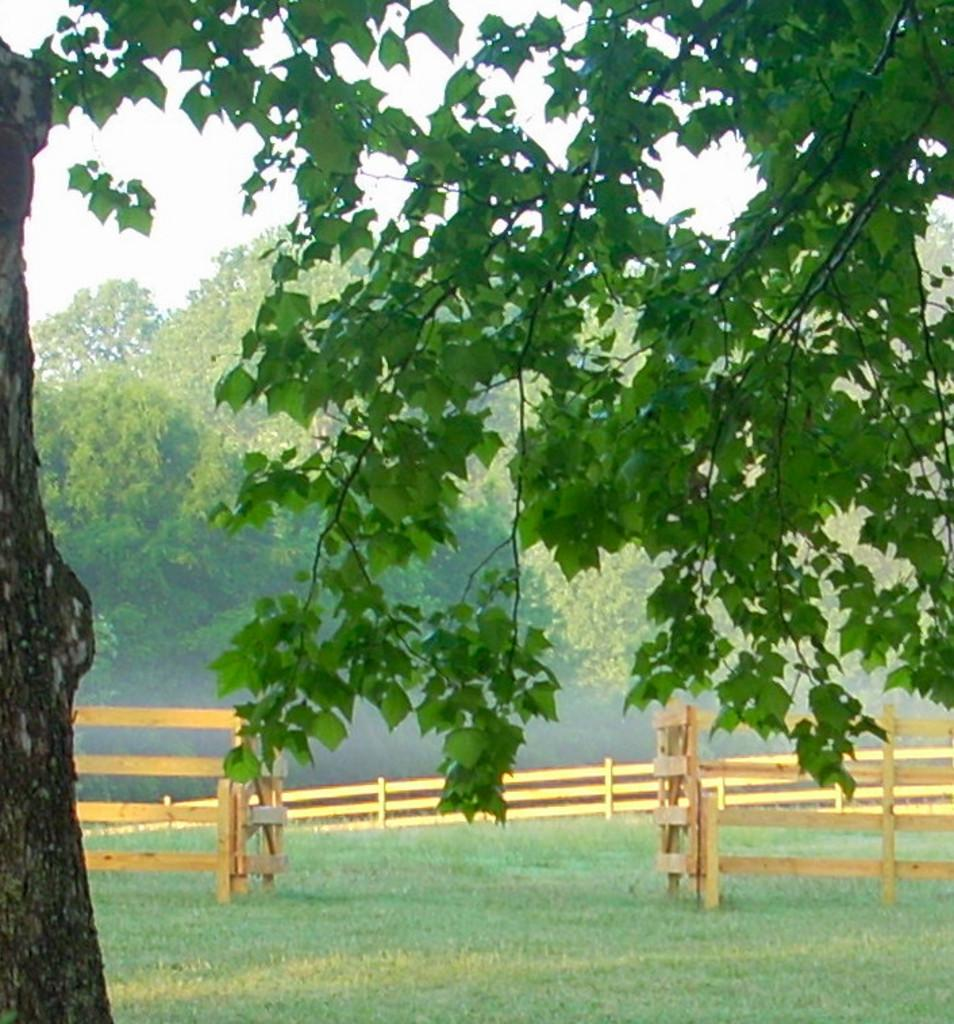What is located in the front of the image? There is a tree in the front of the image. What type of vegetation is on the ground in the center of the image? There is grass on the ground in the center of the image. What type of barrier is present in the center of the image? There is a wooden fence in the center of the image. What can be seen in the background of the image? There are trees in the background of the image. How would you describe the sky in the background of the image? The sky is cloudy in the background of the image. What type of stone can be seen creating waves in the image? There is no stone or waves present in the image. 